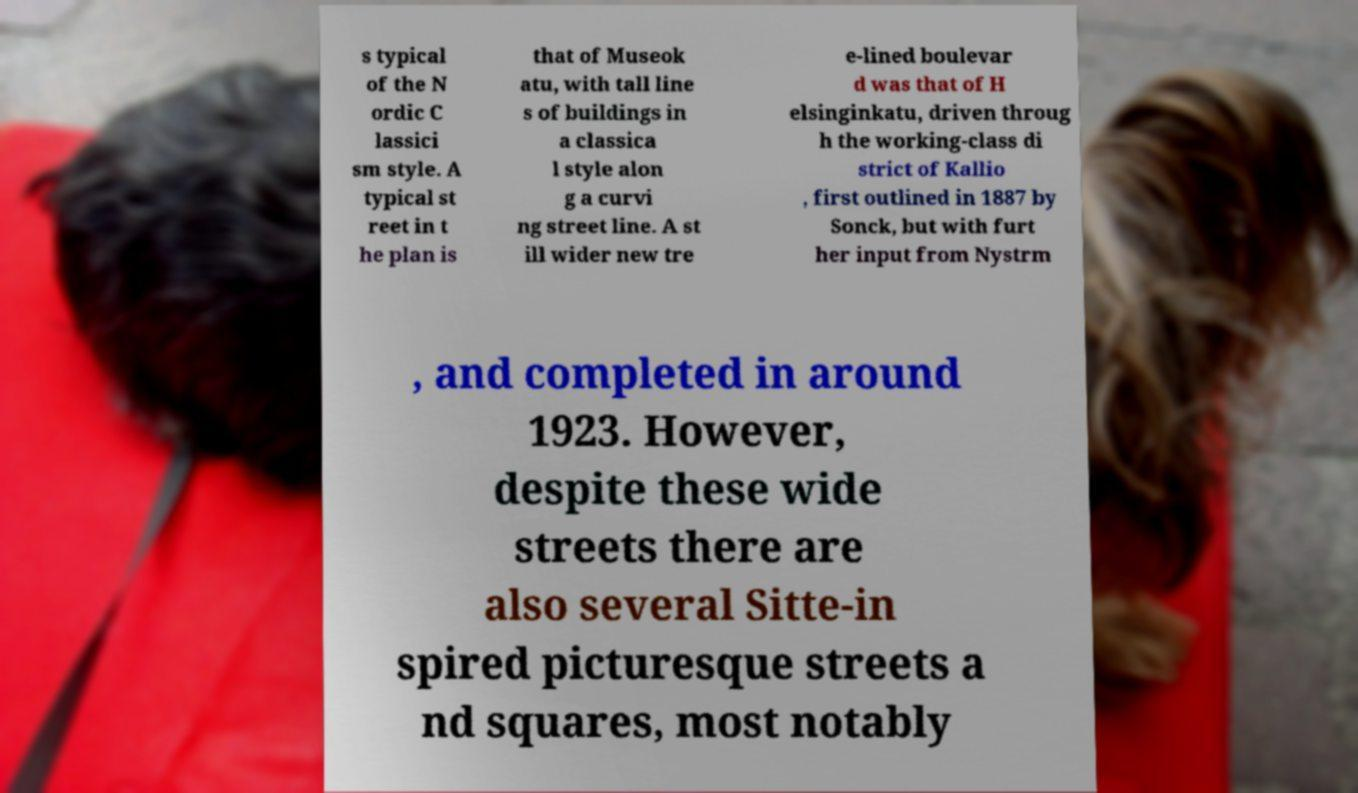Could you extract and type out the text from this image? s typical of the N ordic C lassici sm style. A typical st reet in t he plan is that of Museok atu, with tall line s of buildings in a classica l style alon g a curvi ng street line. A st ill wider new tre e-lined boulevar d was that of H elsinginkatu, driven throug h the working-class di strict of Kallio , first outlined in 1887 by Sonck, but with furt her input from Nystrm , and completed in around 1923. However, despite these wide streets there are also several Sitte-in spired picturesque streets a nd squares, most notably 